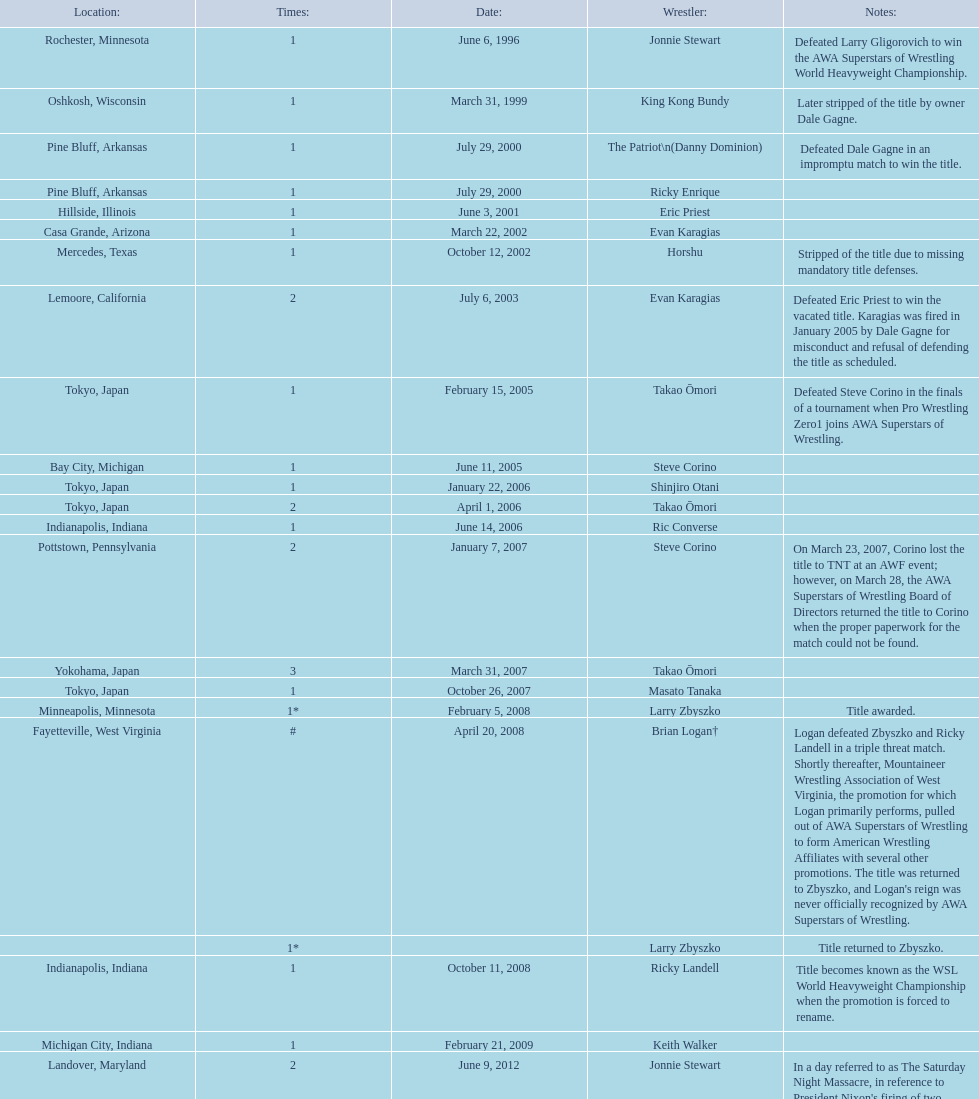The patriot (danny dominion) won the title from what previous holder through an impromptu match? Dale Gagne. 